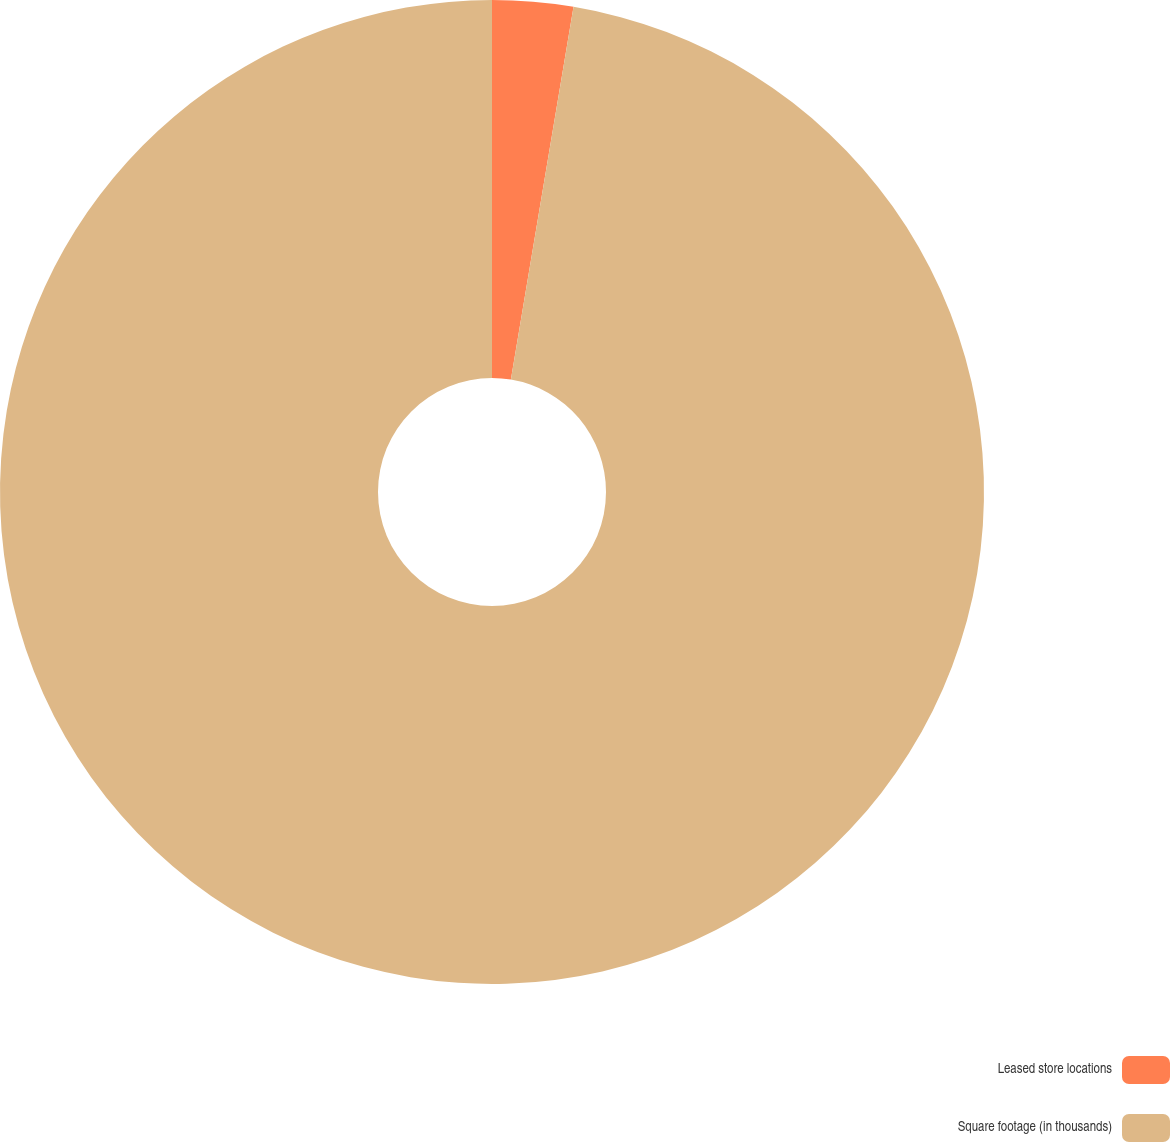<chart> <loc_0><loc_0><loc_500><loc_500><pie_chart><fcel>Leased store locations<fcel>Square footage (in thousands)<nl><fcel>2.65%<fcel>97.35%<nl></chart> 